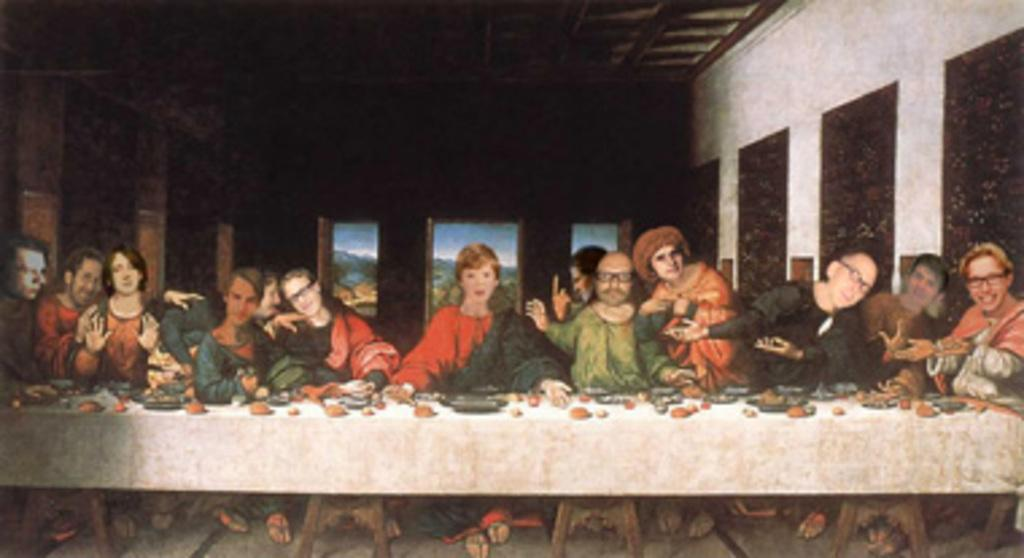What are the people in the image doing? There is a group of people sitting in the image. What is in front of the group of people? There is a table in front of the group of people. What color is the wall in the image? The wall in the image is white in color. What type of comb is being used by the secretary in the image? There is no secretary or comb present in the image. How many eggs are on the table in the image? There are no eggs visible on the table in the image. 